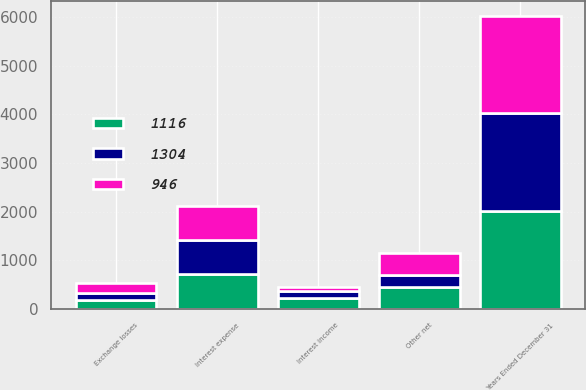Convert chart. <chart><loc_0><loc_0><loc_500><loc_500><stacked_bar_chart><ecel><fcel>Years Ended December 31<fcel>Interest income<fcel>Interest expense<fcel>Exchange losses<fcel>Other net<nl><fcel>1116<fcel>2012<fcel>232<fcel>714<fcel>185<fcel>449<nl><fcel>1304<fcel>2011<fcel>145<fcel>695<fcel>143<fcel>253<nl><fcel>946<fcel>2010<fcel>83<fcel>715<fcel>214<fcel>458<nl></chart> 